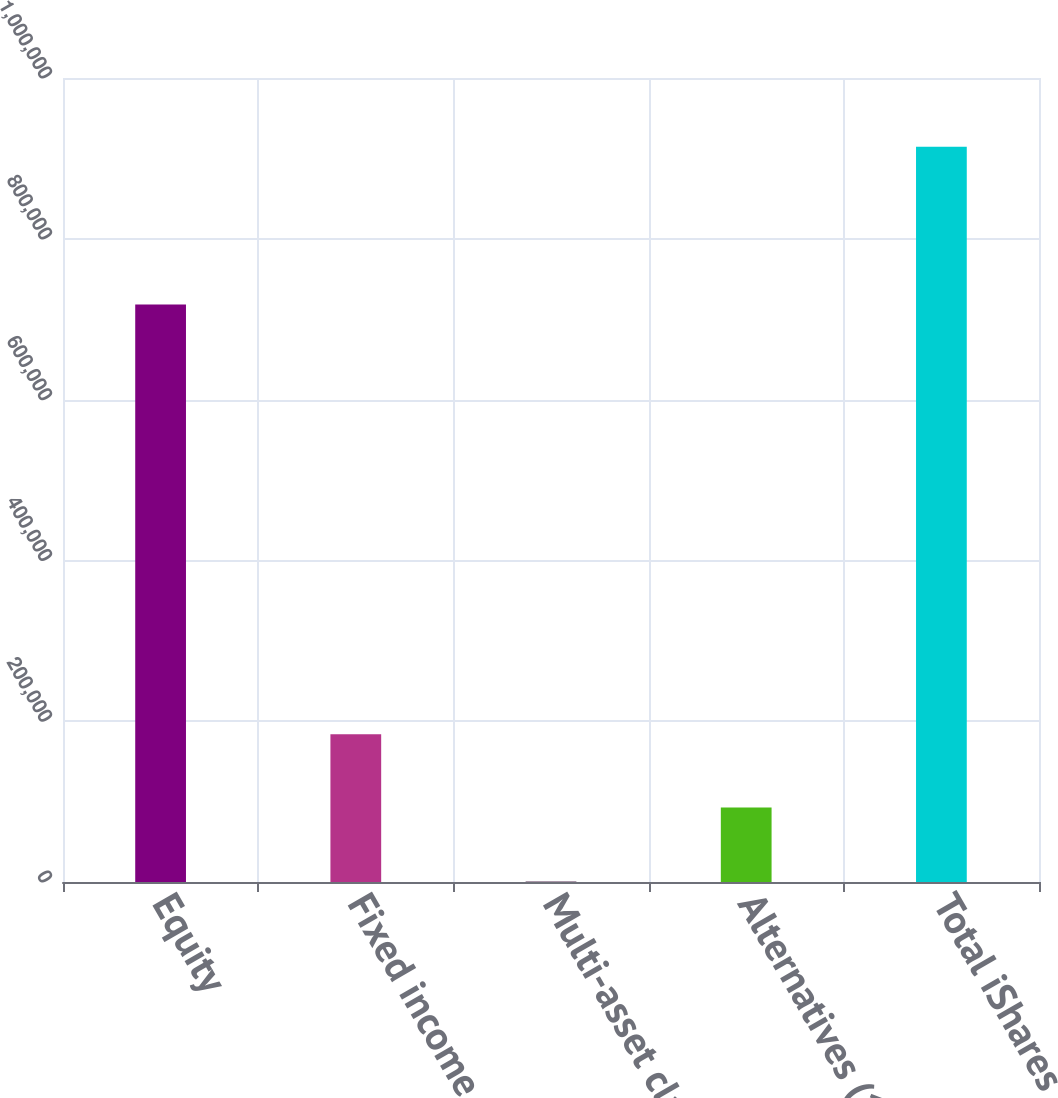Convert chart to OTSL. <chart><loc_0><loc_0><loc_500><loc_500><bar_chart><fcel>Equity<fcel>Fixed income<fcel>Multi-asset class<fcel>Alternatives (1)<fcel>Total iShares<nl><fcel>718135<fcel>183922<fcel>1310<fcel>92616.2<fcel>914372<nl></chart> 